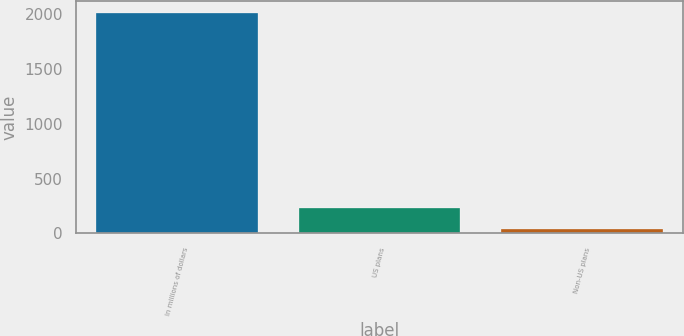Convert chart to OTSL. <chart><loc_0><loc_0><loc_500><loc_500><bar_chart><fcel>In millions of dollars<fcel>US plans<fcel>Non-US plans<nl><fcel>2016<fcel>234.9<fcel>37<nl></chart> 